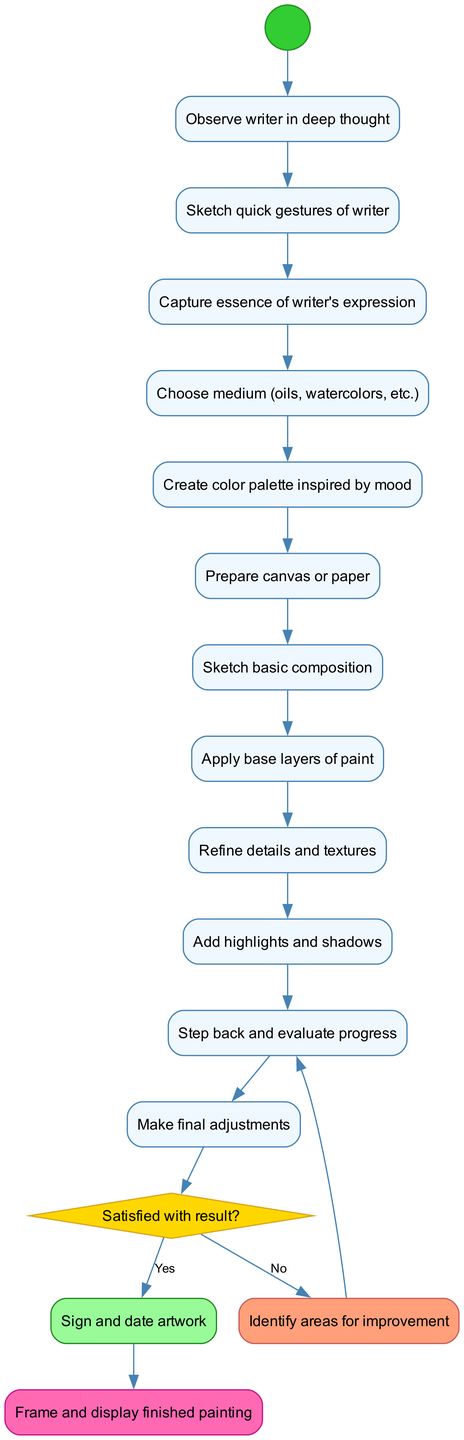What is the initial node of the diagram? The initial node is indicated clearly in the diagram as "Observe writer in deep thought." It serves as the starting point of the creative process for the painter.
Answer: Observe writer in deep thought How many activities are included in the diagram? The diagram contains a total of 10 activities, which outline the various steps taken by the painter from inspiration to completion of the artwork.
Answer: 10 What is the final node of the diagram? The final node is defined as "Frame and display finished painting." This indicates the end of the creative process once the artwork is completed.
Answer: Frame and display finished painting What are the outcomes of the decision node? The decision node offers two outcomes based on the satisfaction with the result: "Sign and date artwork" for a yes response, and "Identify areas for improvement" for a no response.
Answer: Sign and date artwork; Identify areas for improvement What activity precedes "Step back and evaluate progress"? The activity that comes directly before "Step back and evaluate progress" is "Add highlights and shadows." This sequence shows the refinement process happening before evaluation.
Answer: Add highlights and shadows If the painter is not satisfied with the result, what is the next action? If the painter is not satisfied, the next action is "Identify areas for improvement," which indicates a reflective step to determine what needs to be adjusted.
Answer: Identify areas for improvement Which activity comes after "Create color palette inspired by mood"? The activity that follows "Create color palette inspired by mood" is "Prepare canvas or paper," demonstrating the workflow transition from preparation to execution.
Answer: Prepare canvas or paper Why is there a decision node in the diagram? The decision node is included to represent a critical point in the creative process where the painter assesses satisfaction with their progress, leading to either finalization or further adjustments.
Answer: To assess satisfaction with the result What is the shape of the decision node? The decision node is represented by a diamond shape, which is standard for decision points in activity diagrams, indicating a choice that influences the next steps in the process.
Answer: Diamond 